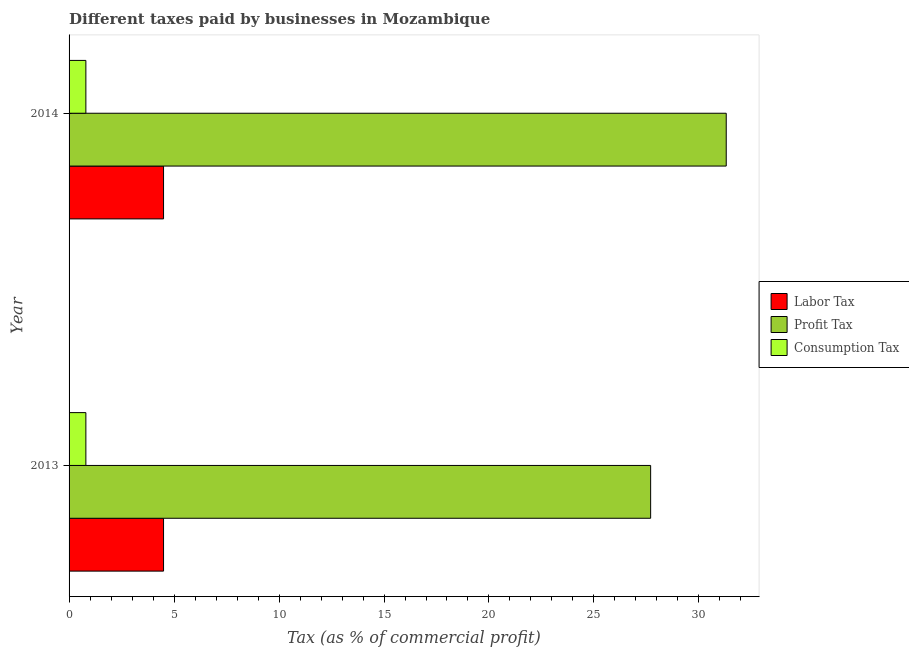How many groups of bars are there?
Make the answer very short. 2. What is the percentage of profit tax in 2013?
Give a very brief answer. 27.7. Across all years, what is the maximum percentage of consumption tax?
Your answer should be very brief. 0.8. Across all years, what is the minimum percentage of profit tax?
Give a very brief answer. 27.7. What is the total percentage of profit tax in the graph?
Offer a very short reply. 59. What is the difference between the percentage of profit tax in 2013 and that in 2014?
Offer a terse response. -3.6. What is the difference between the percentage of profit tax in 2013 and the percentage of labor tax in 2014?
Offer a very short reply. 23.2. In the year 2014, what is the difference between the percentage of consumption tax and percentage of profit tax?
Provide a short and direct response. -30.5. Is the percentage of profit tax in 2013 less than that in 2014?
Your answer should be compact. Yes. In how many years, is the percentage of labor tax greater than the average percentage of labor tax taken over all years?
Your answer should be very brief. 0. What does the 2nd bar from the top in 2013 represents?
Your response must be concise. Profit Tax. What does the 3rd bar from the bottom in 2013 represents?
Provide a succinct answer. Consumption Tax. Is it the case that in every year, the sum of the percentage of labor tax and percentage of profit tax is greater than the percentage of consumption tax?
Keep it short and to the point. Yes. What is the difference between two consecutive major ticks on the X-axis?
Ensure brevity in your answer.  5. Are the values on the major ticks of X-axis written in scientific E-notation?
Make the answer very short. No. Does the graph contain grids?
Make the answer very short. No. How are the legend labels stacked?
Your answer should be very brief. Vertical. What is the title of the graph?
Give a very brief answer. Different taxes paid by businesses in Mozambique. Does "Taxes" appear as one of the legend labels in the graph?
Offer a terse response. No. What is the label or title of the X-axis?
Ensure brevity in your answer.  Tax (as % of commercial profit). What is the Tax (as % of commercial profit) in Labor Tax in 2013?
Offer a very short reply. 4.5. What is the Tax (as % of commercial profit) in Profit Tax in 2013?
Offer a very short reply. 27.7. What is the Tax (as % of commercial profit) in Consumption Tax in 2013?
Offer a terse response. 0.8. What is the Tax (as % of commercial profit) in Profit Tax in 2014?
Offer a terse response. 31.3. What is the Tax (as % of commercial profit) of Consumption Tax in 2014?
Keep it short and to the point. 0.8. Across all years, what is the maximum Tax (as % of commercial profit) in Profit Tax?
Your response must be concise. 31.3. Across all years, what is the minimum Tax (as % of commercial profit) of Profit Tax?
Offer a terse response. 27.7. What is the total Tax (as % of commercial profit) of Labor Tax in the graph?
Ensure brevity in your answer.  9. What is the difference between the Tax (as % of commercial profit) of Profit Tax in 2013 and that in 2014?
Offer a very short reply. -3.6. What is the difference between the Tax (as % of commercial profit) in Labor Tax in 2013 and the Tax (as % of commercial profit) in Profit Tax in 2014?
Keep it short and to the point. -26.8. What is the difference between the Tax (as % of commercial profit) in Labor Tax in 2013 and the Tax (as % of commercial profit) in Consumption Tax in 2014?
Keep it short and to the point. 3.7. What is the difference between the Tax (as % of commercial profit) in Profit Tax in 2013 and the Tax (as % of commercial profit) in Consumption Tax in 2014?
Provide a succinct answer. 26.9. What is the average Tax (as % of commercial profit) of Labor Tax per year?
Provide a short and direct response. 4.5. What is the average Tax (as % of commercial profit) in Profit Tax per year?
Your response must be concise. 29.5. What is the average Tax (as % of commercial profit) of Consumption Tax per year?
Offer a very short reply. 0.8. In the year 2013, what is the difference between the Tax (as % of commercial profit) in Labor Tax and Tax (as % of commercial profit) in Profit Tax?
Provide a short and direct response. -23.2. In the year 2013, what is the difference between the Tax (as % of commercial profit) of Profit Tax and Tax (as % of commercial profit) of Consumption Tax?
Provide a short and direct response. 26.9. In the year 2014, what is the difference between the Tax (as % of commercial profit) in Labor Tax and Tax (as % of commercial profit) in Profit Tax?
Offer a very short reply. -26.8. In the year 2014, what is the difference between the Tax (as % of commercial profit) of Profit Tax and Tax (as % of commercial profit) of Consumption Tax?
Make the answer very short. 30.5. What is the ratio of the Tax (as % of commercial profit) in Profit Tax in 2013 to that in 2014?
Your response must be concise. 0.89. What is the ratio of the Tax (as % of commercial profit) in Consumption Tax in 2013 to that in 2014?
Keep it short and to the point. 1. What is the difference between the highest and the lowest Tax (as % of commercial profit) of Profit Tax?
Make the answer very short. 3.6. 